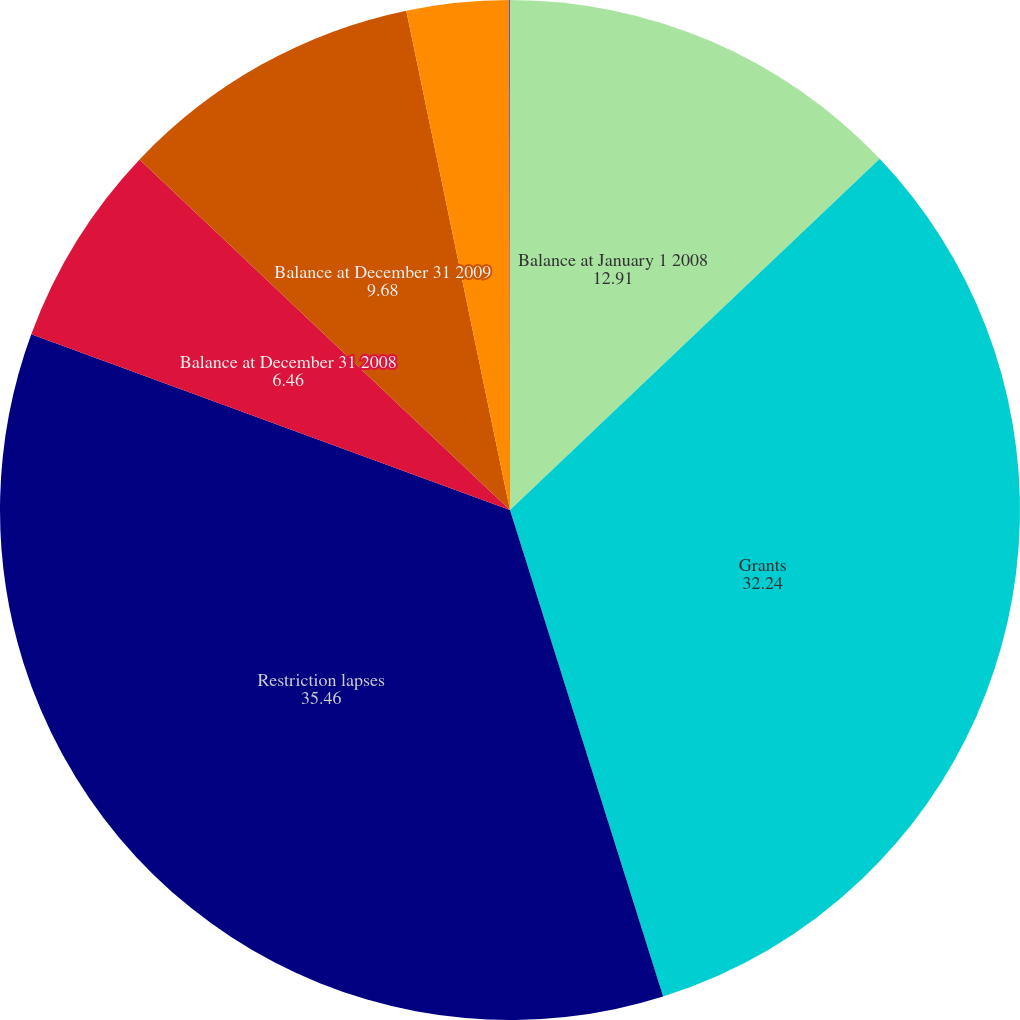Convert chart to OTSL. <chart><loc_0><loc_0><loc_500><loc_500><pie_chart><fcel>Balance at January 1 2008<fcel>Grants<fcel>Restriction lapses<fcel>Balance at December 31 2008<fcel>Balance at December 31 2009<fcel>Forfeitures<fcel>Balance at December 31 2010<nl><fcel>12.91%<fcel>32.24%<fcel>35.46%<fcel>6.46%<fcel>9.68%<fcel>3.24%<fcel>0.02%<nl></chart> 